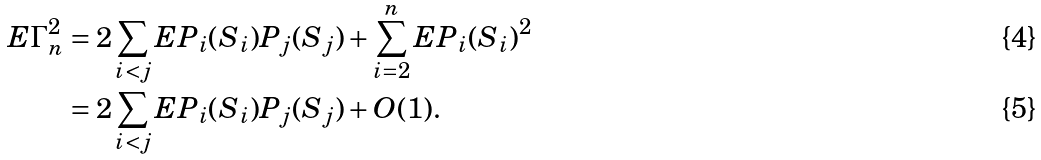Convert formula to latex. <formula><loc_0><loc_0><loc_500><loc_500>E \Gamma _ { n } ^ { 2 } & = 2 \sum _ { i < j } E P _ { i } ( S _ { i } ) P _ { j } ( S _ { j } ) + \sum _ { i = 2 } ^ { n } E P _ { i } ( S _ { i } ) ^ { 2 } \\ & = 2 \sum _ { i < j } E P _ { i } ( S _ { i } ) P _ { j } ( S _ { j } ) + O ( 1 ) .</formula> 